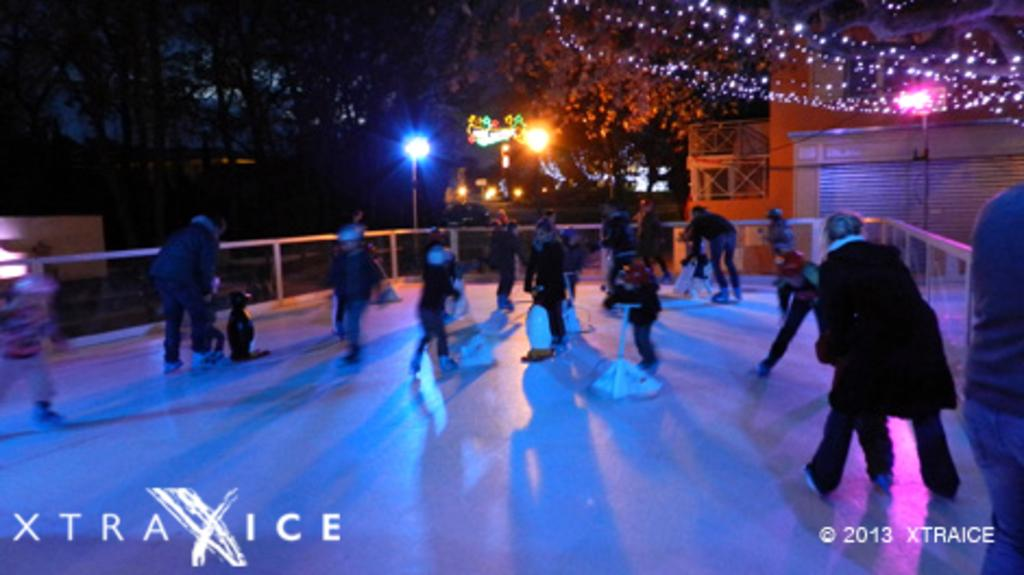Who is present in the image? There are people in the image. What are the people wearing? The people are wearing dresses and ice-skates. What can be seen in the background of the image? There are lights, buildings, and many trees in the background of the image. What type of popcorn is being used as a boundary in the image? There is no popcorn present in the image, and therefore no such boundary can be observed. 